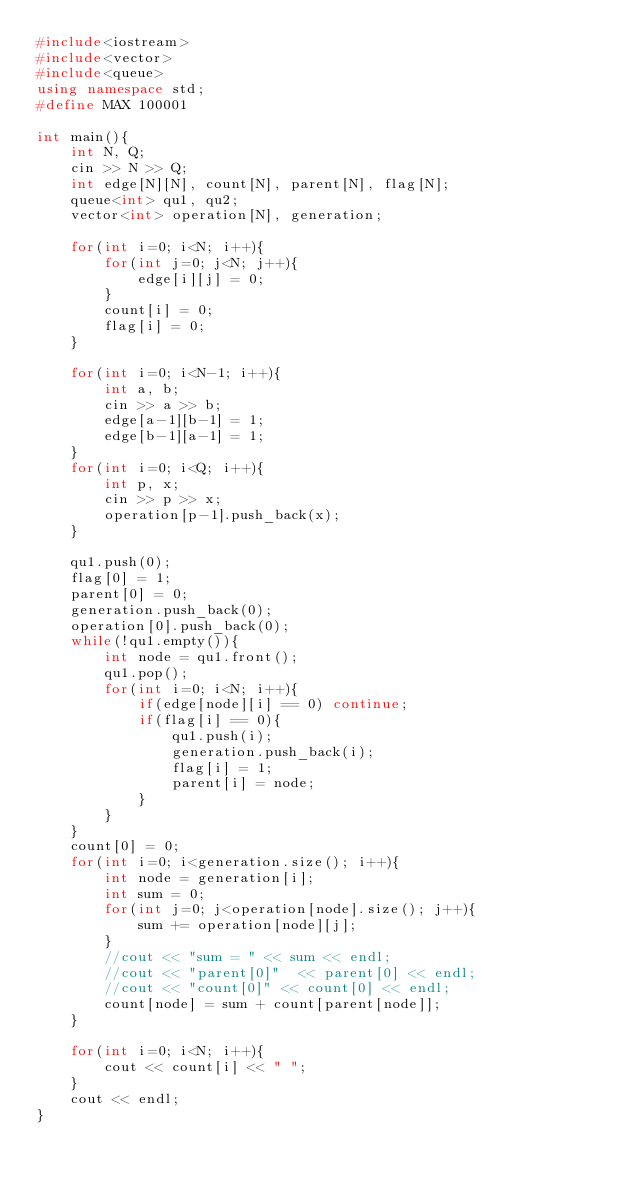<code> <loc_0><loc_0><loc_500><loc_500><_C++_>#include<iostream>
#include<vector>
#include<queue>
using namespace std;
#define MAX 100001

int main(){
    int N, Q;
    cin >> N >> Q;
    int edge[N][N], count[N], parent[N], flag[N];
    queue<int> qu1, qu2;
    vector<int> operation[N], generation;

    for(int i=0; i<N; i++){
        for(int j=0; j<N; j++){
            edge[i][j] = 0;
        }
        count[i] = 0;
        flag[i] = 0;
    }

    for(int i=0; i<N-1; i++){
        int a, b;
        cin >> a >> b;
        edge[a-1][b-1] = 1;
        edge[b-1][a-1] = 1;
    }
    for(int i=0; i<Q; i++){
        int p, x;
        cin >> p >> x;
        operation[p-1].push_back(x);
    }

    qu1.push(0);
    flag[0] = 1;
    parent[0] = 0;
    generation.push_back(0);
    operation[0].push_back(0);
    while(!qu1.empty()){
        int node = qu1.front();
        qu1.pop();
        for(int i=0; i<N; i++){
            if(edge[node][i] == 0) continue;
            if(flag[i] == 0){
                qu1.push(i);
                generation.push_back(i);
                flag[i] = 1;
                parent[i] = node;
            }
        }
    }
    count[0] = 0;
    for(int i=0; i<generation.size(); i++){
        int node = generation[i];
        int sum = 0;
        for(int j=0; j<operation[node].size(); j++){
            sum += operation[node][j];
        }
        //cout << "sum = " << sum << endl;
        //cout << "parent[0]"  << parent[0] << endl;
        //cout << "count[0]" << count[0] << endl;
        count[node] = sum + count[parent[node]];
    }

    for(int i=0; i<N; i++){
        cout << count[i] << " ";
    }
    cout << endl;
}</code> 